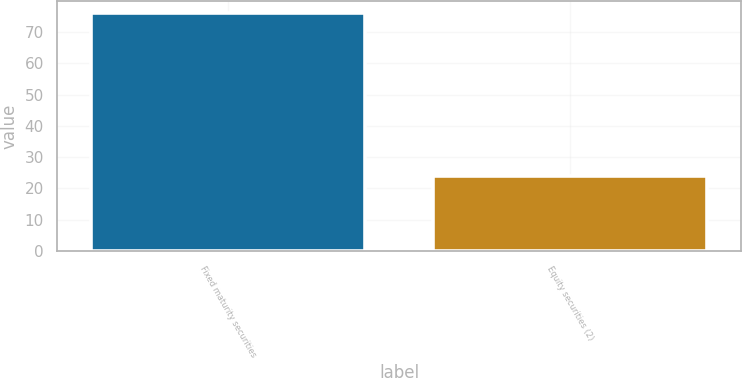Convert chart to OTSL. <chart><loc_0><loc_0><loc_500><loc_500><bar_chart><fcel>Fixed maturity securities<fcel>Equity securities (2)<nl><fcel>76<fcel>24<nl></chart> 